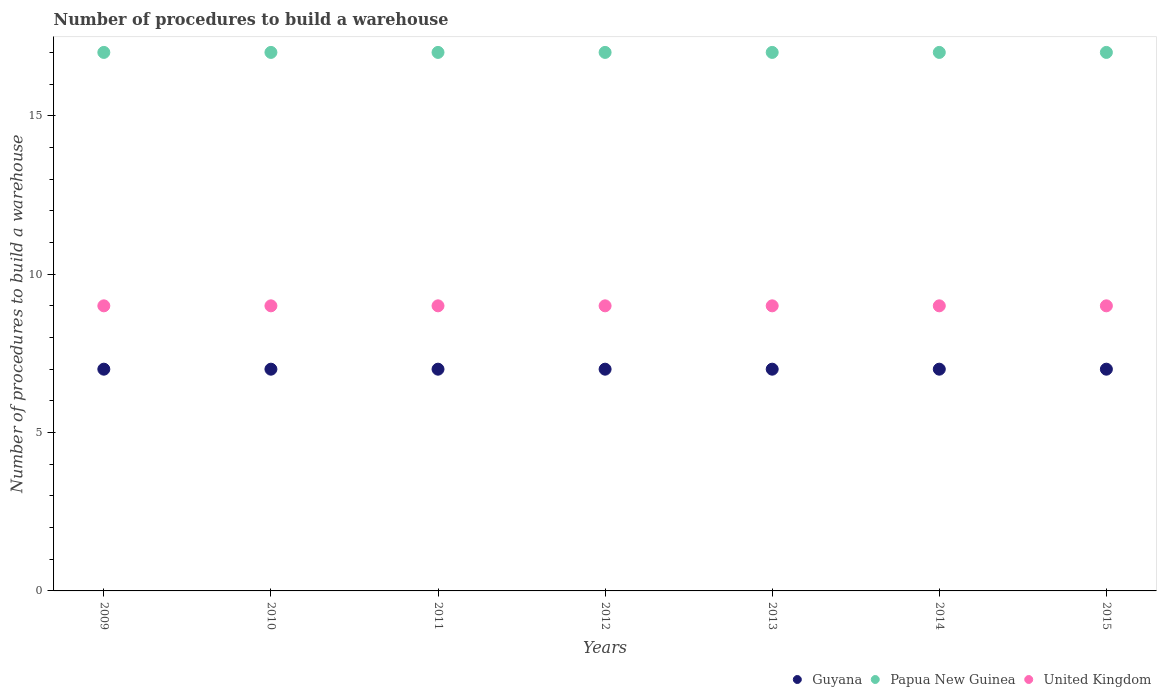How many different coloured dotlines are there?
Provide a succinct answer. 3. Is the number of dotlines equal to the number of legend labels?
Offer a terse response. Yes. What is the number of procedures to build a warehouse in in Papua New Guinea in 2015?
Your response must be concise. 17. Across all years, what is the maximum number of procedures to build a warehouse in in Guyana?
Your answer should be very brief. 7. Across all years, what is the minimum number of procedures to build a warehouse in in Papua New Guinea?
Give a very brief answer. 17. In which year was the number of procedures to build a warehouse in in Papua New Guinea maximum?
Ensure brevity in your answer.  2009. What is the total number of procedures to build a warehouse in in Guyana in the graph?
Provide a succinct answer. 49. What is the difference between the number of procedures to build a warehouse in in Guyana in 2009 and that in 2012?
Provide a succinct answer. 0. What is the difference between the number of procedures to build a warehouse in in Guyana in 2013 and the number of procedures to build a warehouse in in United Kingdom in 2012?
Your answer should be compact. -2. What is the average number of procedures to build a warehouse in in United Kingdom per year?
Your response must be concise. 9. In the year 2013, what is the difference between the number of procedures to build a warehouse in in Guyana and number of procedures to build a warehouse in in Papua New Guinea?
Ensure brevity in your answer.  -10. What is the ratio of the number of procedures to build a warehouse in in Papua New Guinea in 2012 to that in 2013?
Your answer should be compact. 1. What is the difference between the highest and the second highest number of procedures to build a warehouse in in Guyana?
Your response must be concise. 0. Does the number of procedures to build a warehouse in in Guyana monotonically increase over the years?
Offer a very short reply. No. Is the number of procedures to build a warehouse in in United Kingdom strictly less than the number of procedures to build a warehouse in in Papua New Guinea over the years?
Provide a short and direct response. Yes. How many dotlines are there?
Offer a very short reply. 3. How many years are there in the graph?
Keep it short and to the point. 7. What is the difference between two consecutive major ticks on the Y-axis?
Ensure brevity in your answer.  5. Does the graph contain any zero values?
Your answer should be compact. No. Does the graph contain grids?
Keep it short and to the point. No. Where does the legend appear in the graph?
Offer a terse response. Bottom right. How many legend labels are there?
Provide a short and direct response. 3. What is the title of the graph?
Make the answer very short. Number of procedures to build a warehouse. What is the label or title of the Y-axis?
Your answer should be very brief. Number of procedures to build a warehouse. What is the Number of procedures to build a warehouse of Papua New Guinea in 2009?
Your answer should be very brief. 17. What is the Number of procedures to build a warehouse in United Kingdom in 2009?
Provide a succinct answer. 9. What is the Number of procedures to build a warehouse of Guyana in 2010?
Your answer should be compact. 7. What is the Number of procedures to build a warehouse of Papua New Guinea in 2010?
Make the answer very short. 17. What is the Number of procedures to build a warehouse in Guyana in 2011?
Your answer should be very brief. 7. What is the Number of procedures to build a warehouse of United Kingdom in 2011?
Keep it short and to the point. 9. What is the Number of procedures to build a warehouse of Guyana in 2012?
Offer a terse response. 7. What is the Number of procedures to build a warehouse of Papua New Guinea in 2012?
Give a very brief answer. 17. What is the Number of procedures to build a warehouse in United Kingdom in 2012?
Your answer should be very brief. 9. What is the Number of procedures to build a warehouse in United Kingdom in 2013?
Offer a very short reply. 9. What is the Number of procedures to build a warehouse in Guyana in 2014?
Ensure brevity in your answer.  7. What is the Number of procedures to build a warehouse in Papua New Guinea in 2014?
Keep it short and to the point. 17. What is the Number of procedures to build a warehouse in Guyana in 2015?
Your answer should be very brief. 7. What is the Number of procedures to build a warehouse in Papua New Guinea in 2015?
Provide a succinct answer. 17. What is the Number of procedures to build a warehouse of United Kingdom in 2015?
Offer a very short reply. 9. Across all years, what is the maximum Number of procedures to build a warehouse of United Kingdom?
Offer a very short reply. 9. Across all years, what is the minimum Number of procedures to build a warehouse of United Kingdom?
Make the answer very short. 9. What is the total Number of procedures to build a warehouse in Guyana in the graph?
Your answer should be very brief. 49. What is the total Number of procedures to build a warehouse of Papua New Guinea in the graph?
Ensure brevity in your answer.  119. What is the total Number of procedures to build a warehouse in United Kingdom in the graph?
Give a very brief answer. 63. What is the difference between the Number of procedures to build a warehouse in Papua New Guinea in 2009 and that in 2010?
Make the answer very short. 0. What is the difference between the Number of procedures to build a warehouse of United Kingdom in 2009 and that in 2010?
Your response must be concise. 0. What is the difference between the Number of procedures to build a warehouse of United Kingdom in 2009 and that in 2011?
Make the answer very short. 0. What is the difference between the Number of procedures to build a warehouse in United Kingdom in 2009 and that in 2013?
Provide a succinct answer. 0. What is the difference between the Number of procedures to build a warehouse in Guyana in 2009 and that in 2014?
Give a very brief answer. 0. What is the difference between the Number of procedures to build a warehouse in Papua New Guinea in 2009 and that in 2014?
Your answer should be very brief. 0. What is the difference between the Number of procedures to build a warehouse in Guyana in 2009 and that in 2015?
Provide a succinct answer. 0. What is the difference between the Number of procedures to build a warehouse of United Kingdom in 2010 and that in 2011?
Your answer should be very brief. 0. What is the difference between the Number of procedures to build a warehouse in Papua New Guinea in 2010 and that in 2012?
Provide a succinct answer. 0. What is the difference between the Number of procedures to build a warehouse of Guyana in 2010 and that in 2013?
Provide a short and direct response. 0. What is the difference between the Number of procedures to build a warehouse of Papua New Guinea in 2010 and that in 2013?
Provide a short and direct response. 0. What is the difference between the Number of procedures to build a warehouse of United Kingdom in 2010 and that in 2013?
Your response must be concise. 0. What is the difference between the Number of procedures to build a warehouse in Guyana in 2010 and that in 2014?
Offer a very short reply. 0. What is the difference between the Number of procedures to build a warehouse in Papua New Guinea in 2010 and that in 2014?
Provide a short and direct response. 0. What is the difference between the Number of procedures to build a warehouse of United Kingdom in 2010 and that in 2014?
Offer a terse response. 0. What is the difference between the Number of procedures to build a warehouse of Guyana in 2011 and that in 2012?
Give a very brief answer. 0. What is the difference between the Number of procedures to build a warehouse in United Kingdom in 2011 and that in 2012?
Your answer should be very brief. 0. What is the difference between the Number of procedures to build a warehouse in Papua New Guinea in 2011 and that in 2015?
Ensure brevity in your answer.  0. What is the difference between the Number of procedures to build a warehouse in United Kingdom in 2012 and that in 2013?
Make the answer very short. 0. What is the difference between the Number of procedures to build a warehouse in Guyana in 2012 and that in 2014?
Offer a terse response. 0. What is the difference between the Number of procedures to build a warehouse of Papua New Guinea in 2012 and that in 2015?
Your answer should be compact. 0. What is the difference between the Number of procedures to build a warehouse of Papua New Guinea in 2013 and that in 2014?
Offer a very short reply. 0. What is the difference between the Number of procedures to build a warehouse of United Kingdom in 2013 and that in 2014?
Make the answer very short. 0. What is the difference between the Number of procedures to build a warehouse of Guyana in 2013 and that in 2015?
Offer a very short reply. 0. What is the difference between the Number of procedures to build a warehouse in United Kingdom in 2013 and that in 2015?
Your answer should be compact. 0. What is the difference between the Number of procedures to build a warehouse of Guyana in 2014 and that in 2015?
Provide a succinct answer. 0. What is the difference between the Number of procedures to build a warehouse in United Kingdom in 2014 and that in 2015?
Keep it short and to the point. 0. What is the difference between the Number of procedures to build a warehouse in Guyana in 2009 and the Number of procedures to build a warehouse in Papua New Guinea in 2011?
Your answer should be compact. -10. What is the difference between the Number of procedures to build a warehouse of Papua New Guinea in 2009 and the Number of procedures to build a warehouse of United Kingdom in 2011?
Ensure brevity in your answer.  8. What is the difference between the Number of procedures to build a warehouse of Guyana in 2009 and the Number of procedures to build a warehouse of Papua New Guinea in 2012?
Keep it short and to the point. -10. What is the difference between the Number of procedures to build a warehouse in Papua New Guinea in 2009 and the Number of procedures to build a warehouse in United Kingdom in 2012?
Offer a very short reply. 8. What is the difference between the Number of procedures to build a warehouse of Guyana in 2009 and the Number of procedures to build a warehouse of United Kingdom in 2013?
Give a very brief answer. -2. What is the difference between the Number of procedures to build a warehouse of Guyana in 2009 and the Number of procedures to build a warehouse of United Kingdom in 2014?
Your response must be concise. -2. What is the difference between the Number of procedures to build a warehouse in Papua New Guinea in 2009 and the Number of procedures to build a warehouse in United Kingdom in 2014?
Provide a succinct answer. 8. What is the difference between the Number of procedures to build a warehouse of Papua New Guinea in 2009 and the Number of procedures to build a warehouse of United Kingdom in 2015?
Your response must be concise. 8. What is the difference between the Number of procedures to build a warehouse of Guyana in 2010 and the Number of procedures to build a warehouse of United Kingdom in 2011?
Your answer should be very brief. -2. What is the difference between the Number of procedures to build a warehouse of Guyana in 2010 and the Number of procedures to build a warehouse of Papua New Guinea in 2012?
Offer a terse response. -10. What is the difference between the Number of procedures to build a warehouse in Papua New Guinea in 2010 and the Number of procedures to build a warehouse in United Kingdom in 2013?
Ensure brevity in your answer.  8. What is the difference between the Number of procedures to build a warehouse in Guyana in 2010 and the Number of procedures to build a warehouse in Papua New Guinea in 2014?
Ensure brevity in your answer.  -10. What is the difference between the Number of procedures to build a warehouse in Guyana in 2010 and the Number of procedures to build a warehouse in United Kingdom in 2014?
Provide a short and direct response. -2. What is the difference between the Number of procedures to build a warehouse of Guyana in 2010 and the Number of procedures to build a warehouse of United Kingdom in 2015?
Your answer should be very brief. -2. What is the difference between the Number of procedures to build a warehouse in Guyana in 2011 and the Number of procedures to build a warehouse in Papua New Guinea in 2012?
Give a very brief answer. -10. What is the difference between the Number of procedures to build a warehouse in Papua New Guinea in 2011 and the Number of procedures to build a warehouse in United Kingdom in 2012?
Your answer should be compact. 8. What is the difference between the Number of procedures to build a warehouse in Guyana in 2011 and the Number of procedures to build a warehouse in Papua New Guinea in 2013?
Offer a very short reply. -10. What is the difference between the Number of procedures to build a warehouse of Guyana in 2011 and the Number of procedures to build a warehouse of United Kingdom in 2013?
Make the answer very short. -2. What is the difference between the Number of procedures to build a warehouse in Papua New Guinea in 2011 and the Number of procedures to build a warehouse in United Kingdom in 2013?
Provide a succinct answer. 8. What is the difference between the Number of procedures to build a warehouse of Guyana in 2011 and the Number of procedures to build a warehouse of Papua New Guinea in 2014?
Offer a terse response. -10. What is the difference between the Number of procedures to build a warehouse in Guyana in 2011 and the Number of procedures to build a warehouse in Papua New Guinea in 2015?
Your answer should be compact. -10. What is the difference between the Number of procedures to build a warehouse of Guyana in 2011 and the Number of procedures to build a warehouse of United Kingdom in 2015?
Offer a very short reply. -2. What is the difference between the Number of procedures to build a warehouse of Guyana in 2012 and the Number of procedures to build a warehouse of Papua New Guinea in 2013?
Ensure brevity in your answer.  -10. What is the difference between the Number of procedures to build a warehouse in Guyana in 2012 and the Number of procedures to build a warehouse in United Kingdom in 2013?
Your answer should be compact. -2. What is the difference between the Number of procedures to build a warehouse in Guyana in 2012 and the Number of procedures to build a warehouse in United Kingdom in 2014?
Ensure brevity in your answer.  -2. What is the difference between the Number of procedures to build a warehouse of Guyana in 2012 and the Number of procedures to build a warehouse of Papua New Guinea in 2015?
Offer a very short reply. -10. What is the difference between the Number of procedures to build a warehouse of Guyana in 2013 and the Number of procedures to build a warehouse of United Kingdom in 2014?
Make the answer very short. -2. What is the difference between the Number of procedures to build a warehouse of Papua New Guinea in 2013 and the Number of procedures to build a warehouse of United Kingdom in 2014?
Your answer should be very brief. 8. What is the difference between the Number of procedures to build a warehouse in Guyana in 2014 and the Number of procedures to build a warehouse in Papua New Guinea in 2015?
Your answer should be very brief. -10. What is the difference between the Number of procedures to build a warehouse in Papua New Guinea in 2014 and the Number of procedures to build a warehouse in United Kingdom in 2015?
Make the answer very short. 8. What is the average Number of procedures to build a warehouse in United Kingdom per year?
Offer a terse response. 9. In the year 2009, what is the difference between the Number of procedures to build a warehouse in Guyana and Number of procedures to build a warehouse in United Kingdom?
Your answer should be very brief. -2. In the year 2010, what is the difference between the Number of procedures to build a warehouse of Guyana and Number of procedures to build a warehouse of Papua New Guinea?
Your answer should be very brief. -10. In the year 2010, what is the difference between the Number of procedures to build a warehouse in Guyana and Number of procedures to build a warehouse in United Kingdom?
Offer a very short reply. -2. In the year 2011, what is the difference between the Number of procedures to build a warehouse in Guyana and Number of procedures to build a warehouse in United Kingdom?
Make the answer very short. -2. In the year 2013, what is the difference between the Number of procedures to build a warehouse of Guyana and Number of procedures to build a warehouse of Papua New Guinea?
Offer a terse response. -10. In the year 2013, what is the difference between the Number of procedures to build a warehouse in Guyana and Number of procedures to build a warehouse in United Kingdom?
Provide a succinct answer. -2. In the year 2013, what is the difference between the Number of procedures to build a warehouse in Papua New Guinea and Number of procedures to build a warehouse in United Kingdom?
Your response must be concise. 8. In the year 2014, what is the difference between the Number of procedures to build a warehouse of Papua New Guinea and Number of procedures to build a warehouse of United Kingdom?
Your response must be concise. 8. In the year 2015, what is the difference between the Number of procedures to build a warehouse in Guyana and Number of procedures to build a warehouse in United Kingdom?
Offer a very short reply. -2. What is the ratio of the Number of procedures to build a warehouse of Guyana in 2009 to that in 2010?
Provide a succinct answer. 1. What is the ratio of the Number of procedures to build a warehouse of Papua New Guinea in 2009 to that in 2010?
Give a very brief answer. 1. What is the ratio of the Number of procedures to build a warehouse in United Kingdom in 2009 to that in 2010?
Make the answer very short. 1. What is the ratio of the Number of procedures to build a warehouse of Guyana in 2009 to that in 2011?
Your answer should be compact. 1. What is the ratio of the Number of procedures to build a warehouse in Papua New Guinea in 2009 to that in 2012?
Your answer should be very brief. 1. What is the ratio of the Number of procedures to build a warehouse of United Kingdom in 2009 to that in 2012?
Offer a very short reply. 1. What is the ratio of the Number of procedures to build a warehouse of Papua New Guinea in 2009 to that in 2013?
Give a very brief answer. 1. What is the ratio of the Number of procedures to build a warehouse in Guyana in 2009 to that in 2014?
Give a very brief answer. 1. What is the ratio of the Number of procedures to build a warehouse in United Kingdom in 2009 to that in 2014?
Your response must be concise. 1. What is the ratio of the Number of procedures to build a warehouse in Guyana in 2009 to that in 2015?
Your response must be concise. 1. What is the ratio of the Number of procedures to build a warehouse of United Kingdom in 2009 to that in 2015?
Provide a short and direct response. 1. What is the ratio of the Number of procedures to build a warehouse of Papua New Guinea in 2010 to that in 2011?
Provide a short and direct response. 1. What is the ratio of the Number of procedures to build a warehouse of Guyana in 2010 to that in 2014?
Ensure brevity in your answer.  1. What is the ratio of the Number of procedures to build a warehouse in United Kingdom in 2010 to that in 2014?
Your response must be concise. 1. What is the ratio of the Number of procedures to build a warehouse of Guyana in 2010 to that in 2015?
Make the answer very short. 1. What is the ratio of the Number of procedures to build a warehouse of Guyana in 2011 to that in 2012?
Your response must be concise. 1. What is the ratio of the Number of procedures to build a warehouse of Papua New Guinea in 2011 to that in 2012?
Make the answer very short. 1. What is the ratio of the Number of procedures to build a warehouse in United Kingdom in 2011 to that in 2012?
Your answer should be compact. 1. What is the ratio of the Number of procedures to build a warehouse of United Kingdom in 2011 to that in 2013?
Make the answer very short. 1. What is the ratio of the Number of procedures to build a warehouse of Papua New Guinea in 2011 to that in 2014?
Provide a short and direct response. 1. What is the ratio of the Number of procedures to build a warehouse in Guyana in 2011 to that in 2015?
Ensure brevity in your answer.  1. What is the ratio of the Number of procedures to build a warehouse in Papua New Guinea in 2011 to that in 2015?
Keep it short and to the point. 1. What is the ratio of the Number of procedures to build a warehouse in Guyana in 2012 to that in 2013?
Keep it short and to the point. 1. What is the ratio of the Number of procedures to build a warehouse in Guyana in 2012 to that in 2014?
Your answer should be very brief. 1. What is the ratio of the Number of procedures to build a warehouse in Papua New Guinea in 2012 to that in 2015?
Make the answer very short. 1. What is the ratio of the Number of procedures to build a warehouse of Papua New Guinea in 2013 to that in 2014?
Your answer should be compact. 1. What is the ratio of the Number of procedures to build a warehouse of Papua New Guinea in 2013 to that in 2015?
Offer a terse response. 1. What is the ratio of the Number of procedures to build a warehouse of Guyana in 2014 to that in 2015?
Your answer should be compact. 1. What is the difference between the highest and the second highest Number of procedures to build a warehouse in Guyana?
Provide a succinct answer. 0. What is the difference between the highest and the lowest Number of procedures to build a warehouse of Papua New Guinea?
Provide a short and direct response. 0. What is the difference between the highest and the lowest Number of procedures to build a warehouse of United Kingdom?
Offer a very short reply. 0. 